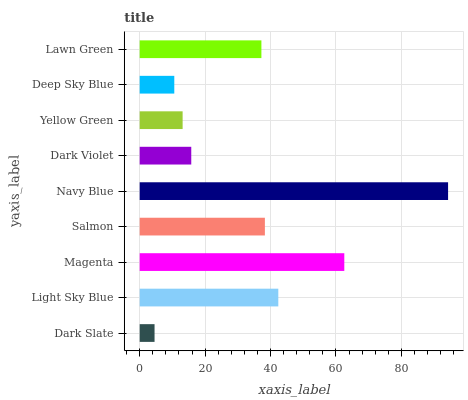Is Dark Slate the minimum?
Answer yes or no. Yes. Is Navy Blue the maximum?
Answer yes or no. Yes. Is Light Sky Blue the minimum?
Answer yes or no. No. Is Light Sky Blue the maximum?
Answer yes or no. No. Is Light Sky Blue greater than Dark Slate?
Answer yes or no. Yes. Is Dark Slate less than Light Sky Blue?
Answer yes or no. Yes. Is Dark Slate greater than Light Sky Blue?
Answer yes or no. No. Is Light Sky Blue less than Dark Slate?
Answer yes or no. No. Is Lawn Green the high median?
Answer yes or no. Yes. Is Lawn Green the low median?
Answer yes or no. Yes. Is Navy Blue the high median?
Answer yes or no. No. Is Magenta the low median?
Answer yes or no. No. 